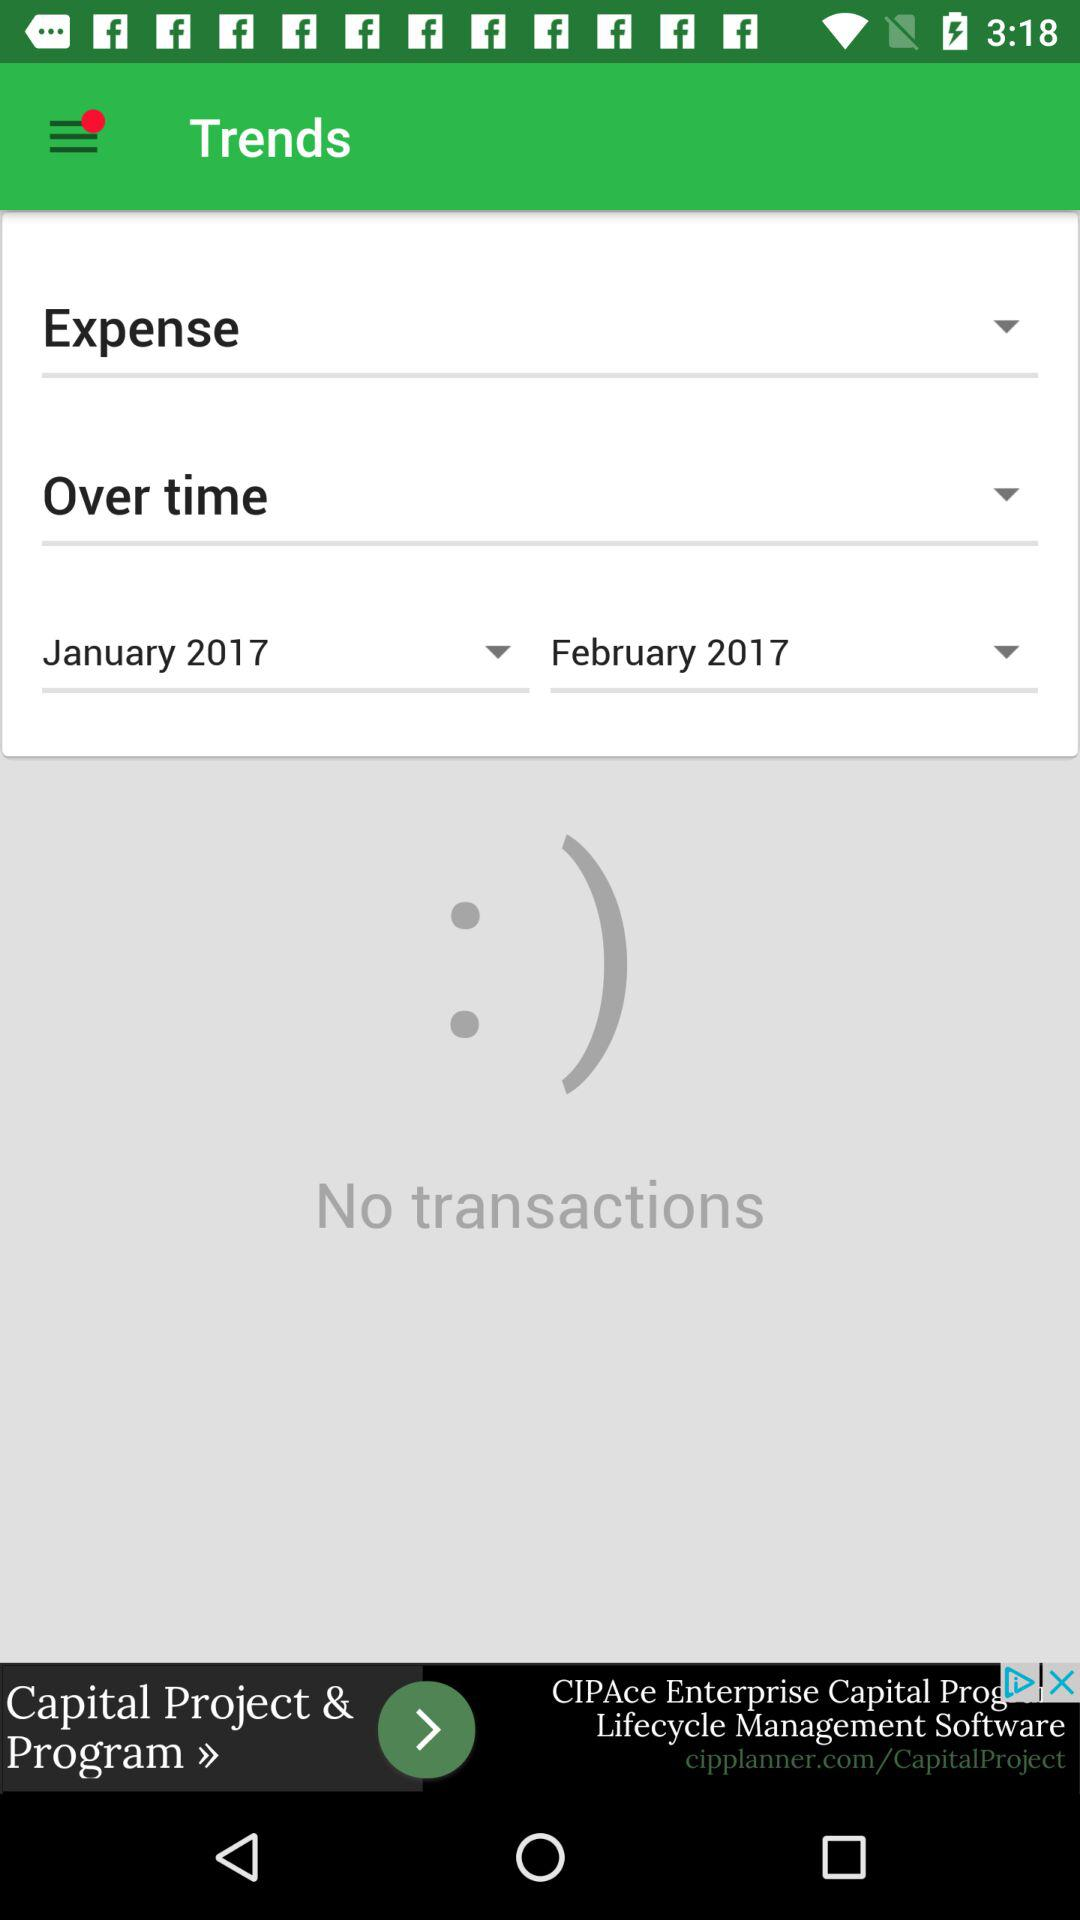How many months are represented in the chart?
Answer the question using a single word or phrase. 2 